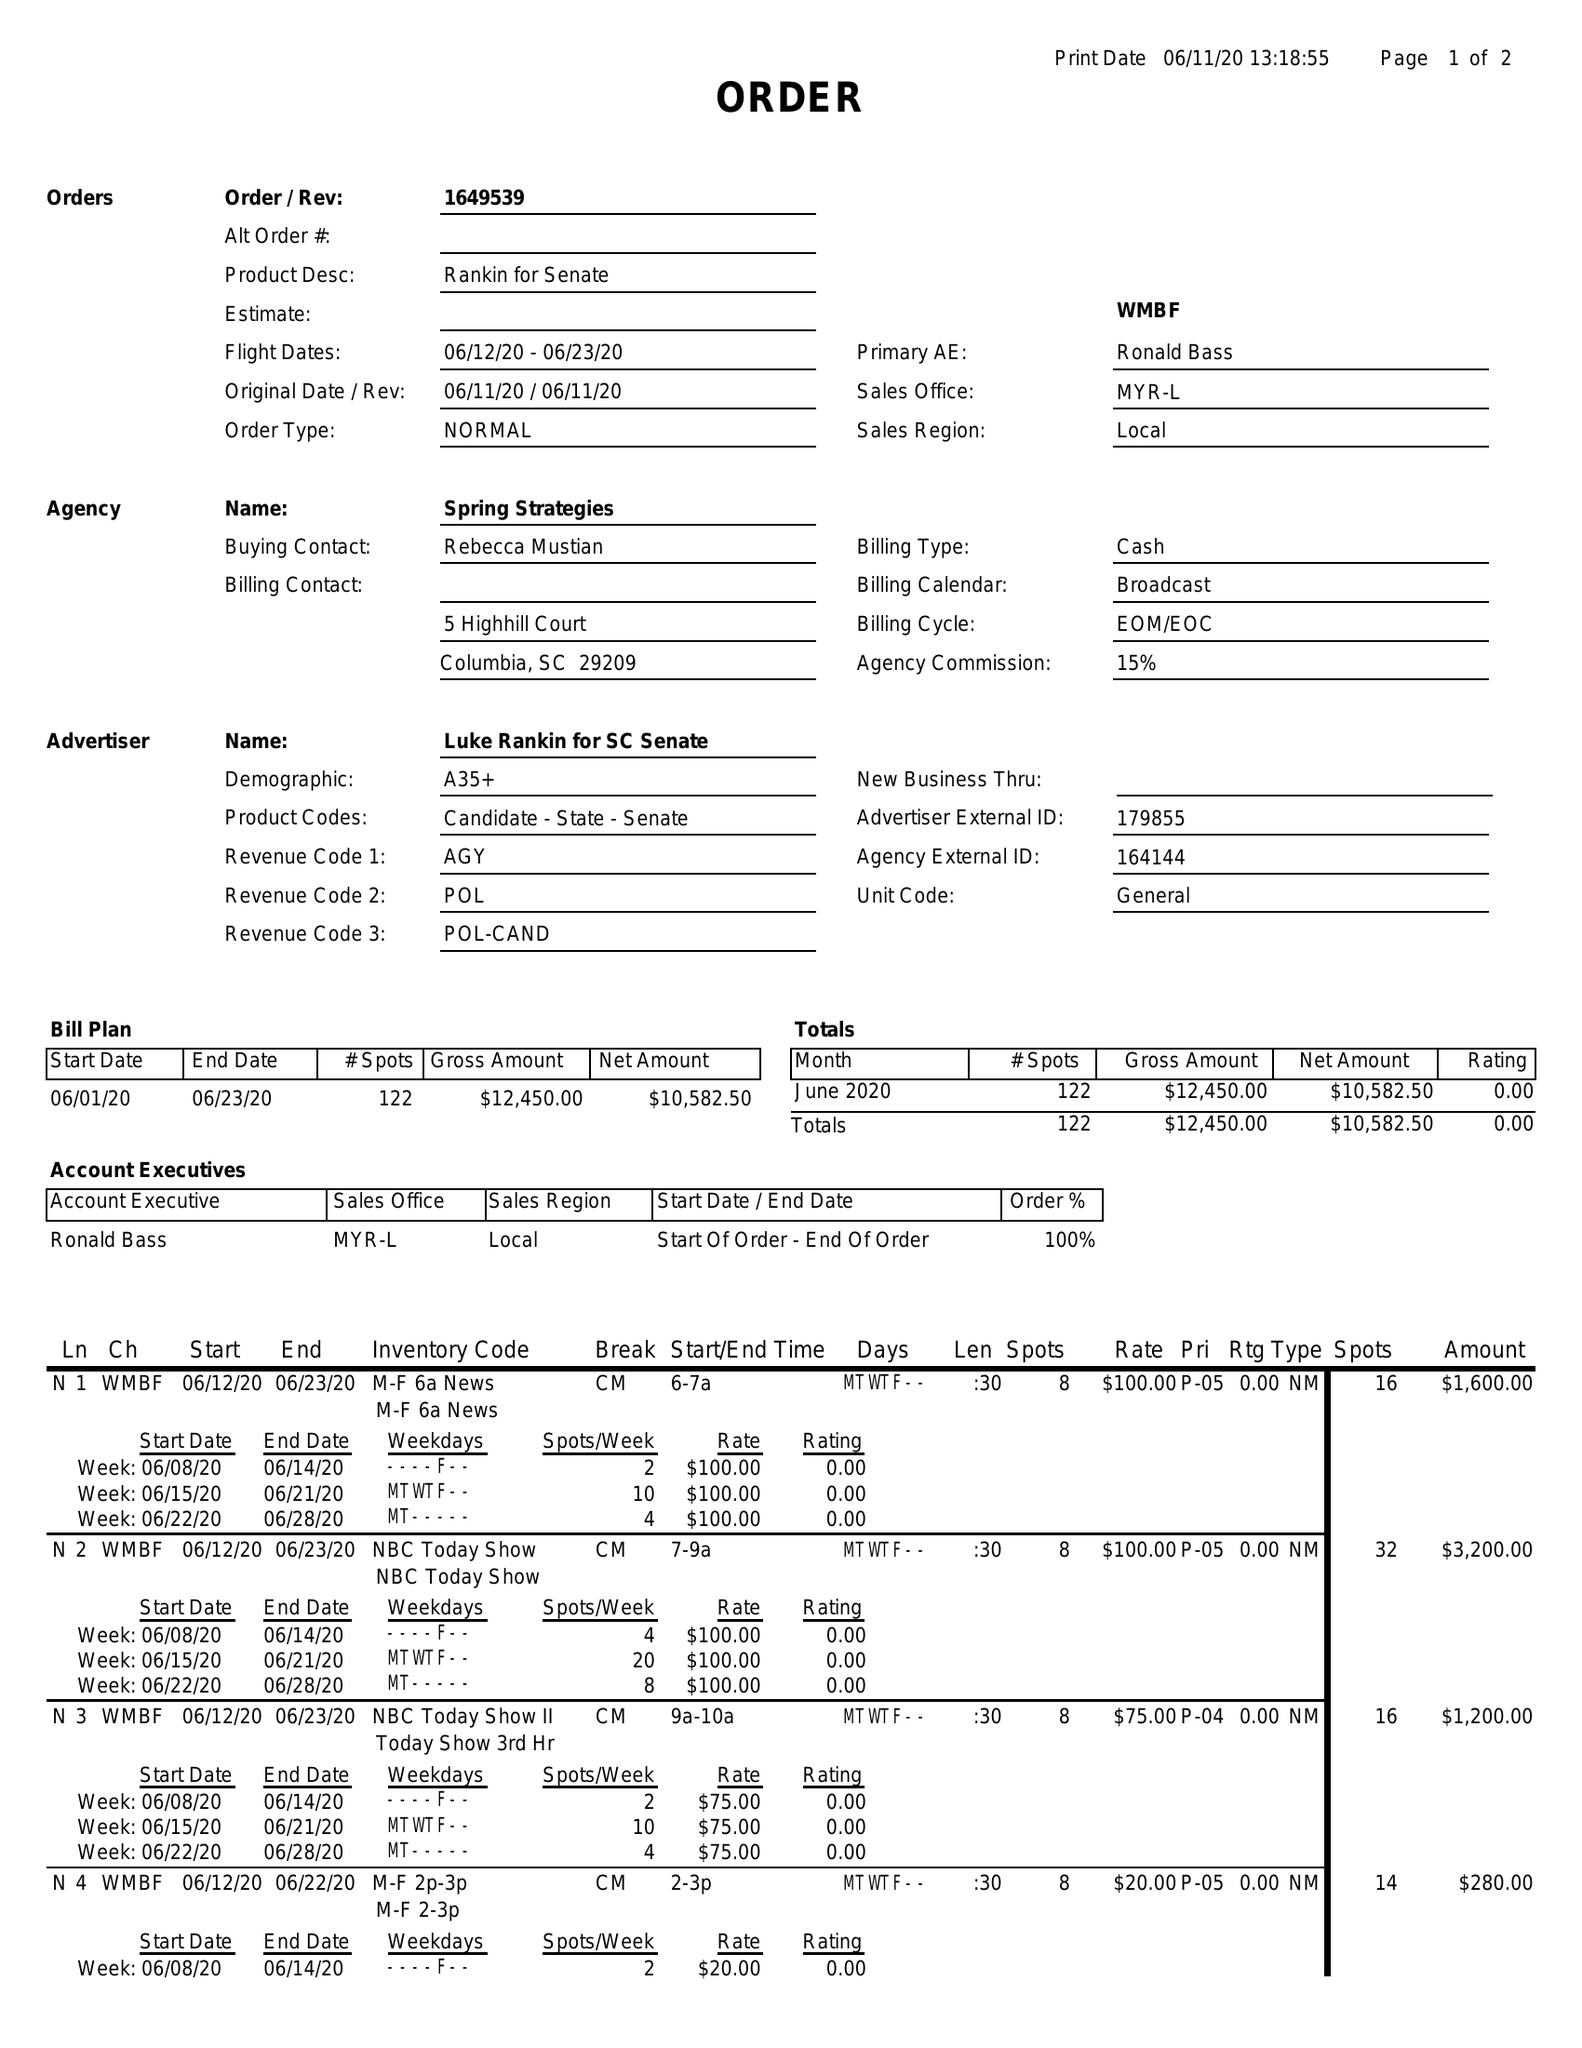What is the value for the gross_amount?
Answer the question using a single word or phrase. 12450.00 